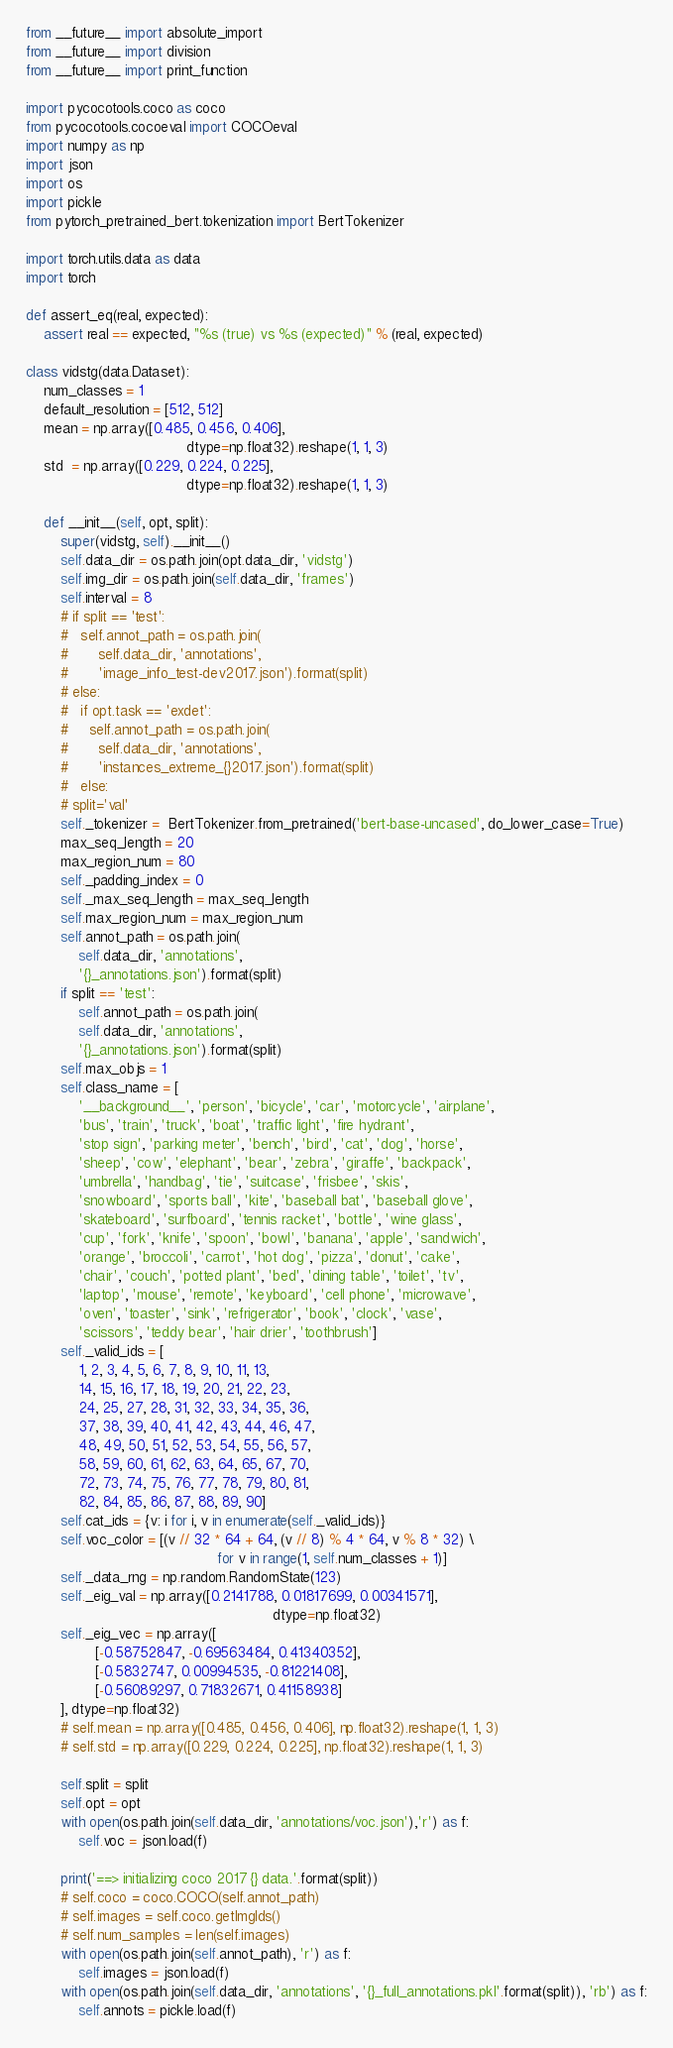<code> <loc_0><loc_0><loc_500><loc_500><_Python_>from __future__ import absolute_import
from __future__ import division
from __future__ import print_function

import pycocotools.coco as coco
from pycocotools.cocoeval import COCOeval
import numpy as np
import json
import os
import pickle
from pytorch_pretrained_bert.tokenization import BertTokenizer

import torch.utils.data as data
import torch

def assert_eq(real, expected):
	assert real == expected, "%s (true) vs %s (expected)" % (real, expected)

class vidstg(data.Dataset):
	num_classes = 1
	default_resolution = [512, 512]
	mean = np.array([0.485, 0.456, 0.406],
									 dtype=np.float32).reshape(1, 1, 3)
	std  = np.array([0.229, 0.224, 0.225],
									 dtype=np.float32).reshape(1, 1, 3)

	def __init__(self, opt, split):
		super(vidstg, self).__init__()
		self.data_dir = os.path.join(opt.data_dir, 'vidstg')
		self.img_dir = os.path.join(self.data_dir, 'frames')
		self.interval = 8
		# if split == 'test':
		#   self.annot_path = os.path.join(
		#       self.data_dir, 'annotations', 
		#       'image_info_test-dev2017.json').format(split)
		# else:
		#   if opt.task == 'exdet':
		#     self.annot_path = os.path.join(
		#       self.data_dir, 'annotations', 
		#       'instances_extreme_{}2017.json').format(split)
		#   else:
		# split='val'
		self._tokenizer =  BertTokenizer.from_pretrained('bert-base-uncased', do_lower_case=True)
		max_seq_length = 20
		max_region_num = 80
		self._padding_index = 0
		self._max_seq_length = max_seq_length
		self.max_region_num = max_region_num
		self.annot_path = os.path.join(
			self.data_dir, 'annotations', 
			'{}_annotations.json').format(split)
		if split == 'test':
			self.annot_path = os.path.join(
			self.data_dir, 'annotations', 
			'{}_annotations.json').format(split)
		self.max_objs = 1
		self.class_name = [
			'__background__', 'person', 'bicycle', 'car', 'motorcycle', 'airplane',
			'bus', 'train', 'truck', 'boat', 'traffic light', 'fire hydrant',
			'stop sign', 'parking meter', 'bench', 'bird', 'cat', 'dog', 'horse',
			'sheep', 'cow', 'elephant', 'bear', 'zebra', 'giraffe', 'backpack',
			'umbrella', 'handbag', 'tie', 'suitcase', 'frisbee', 'skis',
			'snowboard', 'sports ball', 'kite', 'baseball bat', 'baseball glove',
			'skateboard', 'surfboard', 'tennis racket', 'bottle', 'wine glass',
			'cup', 'fork', 'knife', 'spoon', 'bowl', 'banana', 'apple', 'sandwich',
			'orange', 'broccoli', 'carrot', 'hot dog', 'pizza', 'donut', 'cake',
			'chair', 'couch', 'potted plant', 'bed', 'dining table', 'toilet', 'tv',
			'laptop', 'mouse', 'remote', 'keyboard', 'cell phone', 'microwave',
			'oven', 'toaster', 'sink', 'refrigerator', 'book', 'clock', 'vase',
			'scissors', 'teddy bear', 'hair drier', 'toothbrush']
		self._valid_ids = [
			1, 2, 3, 4, 5, 6, 7, 8, 9, 10, 11, 13, 
			14, 15, 16, 17, 18, 19, 20, 21, 22, 23, 
			24, 25, 27, 28, 31, 32, 33, 34, 35, 36, 
			37, 38, 39, 40, 41, 42, 43, 44, 46, 47, 
			48, 49, 50, 51, 52, 53, 54, 55, 56, 57, 
			58, 59, 60, 61, 62, 63, 64, 65, 67, 70, 
			72, 73, 74, 75, 76, 77, 78, 79, 80, 81, 
			82, 84, 85, 86, 87, 88, 89, 90]
		self.cat_ids = {v: i for i, v in enumerate(self._valid_ids)}
		self.voc_color = [(v // 32 * 64 + 64, (v // 8) % 4 * 64, v % 8 * 32) \
											for v in range(1, self.num_classes + 1)]
		self._data_rng = np.random.RandomState(123)
		self._eig_val = np.array([0.2141788, 0.01817699, 0.00341571],
														 dtype=np.float32)
		self._eig_vec = np.array([
				[-0.58752847, -0.69563484, 0.41340352],
				[-0.5832747, 0.00994535, -0.81221408],
				[-0.56089297, 0.71832671, 0.41158938]
		], dtype=np.float32)
		# self.mean = np.array([0.485, 0.456, 0.406], np.float32).reshape(1, 1, 3)
		# self.std = np.array([0.229, 0.224, 0.225], np.float32).reshape(1, 1, 3)

		self.split = split
		self.opt = opt
		with open(os.path.join(self.data_dir, 'annotations/voc.json'),'r') as f:
			self.voc = json.load(f)

		print('==> initializing coco 2017 {} data.'.format(split))
		# self.coco = coco.COCO(self.annot_path)
		# self.images = self.coco.getImgIds()
		# self.num_samples = len(self.images)
		with open(os.path.join(self.annot_path), 'r') as f:
			self.images = json.load(f)
		with open(os.path.join(self.data_dir, 'annotations', '{}_full_annotations.pkl'.format(split)), 'rb') as f:
			self.annots = pickle.load(f)</code> 